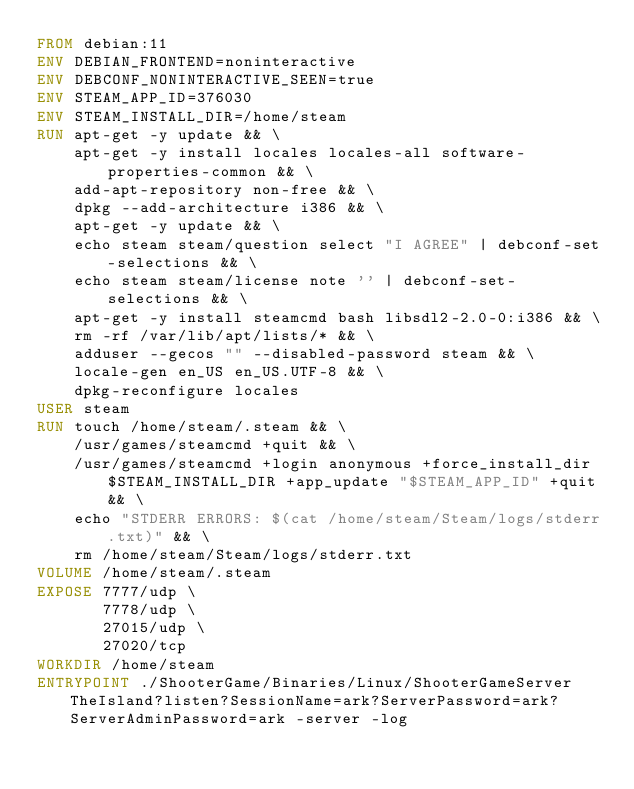Convert code to text. <code><loc_0><loc_0><loc_500><loc_500><_Dockerfile_>FROM debian:11
ENV DEBIAN_FRONTEND=noninteractive
ENV DEBCONF_NONINTERACTIVE_SEEN=true
ENV STEAM_APP_ID=376030
ENV STEAM_INSTALL_DIR=/home/steam
RUN apt-get -y update && \
    apt-get -y install locales locales-all software-properties-common && \
    add-apt-repository non-free && \
    dpkg --add-architecture i386 && \
    apt-get -y update && \
    echo steam steam/question select "I AGREE" | debconf-set-selections && \
    echo steam steam/license note '' | debconf-set-selections && \
    apt-get -y install steamcmd bash libsdl2-2.0-0:i386 && \
    rm -rf /var/lib/apt/lists/* && \
    adduser --gecos "" --disabled-password steam && \
    locale-gen en_US en_US.UTF-8 && \
    dpkg-reconfigure locales
USER steam
RUN touch /home/steam/.steam && \
    /usr/games/steamcmd +quit && \
    /usr/games/steamcmd +login anonymous +force_install_dir $STEAM_INSTALL_DIR +app_update "$STEAM_APP_ID" +quit && \
    echo "STDERR ERRORS: $(cat /home/steam/Steam/logs/stderr.txt)" && \
    rm /home/steam/Steam/logs/stderr.txt
VOLUME /home/steam/.steam
EXPOSE 7777/udp \
       7778/udp \
       27015/udp \
       27020/tcp
WORKDIR /home/steam
ENTRYPOINT ./ShooterGame/Binaries/Linux/ShooterGameServer TheIsland?listen?SessionName=ark?ServerPassword=ark?ServerAdminPassword=ark -server -log
</code> 